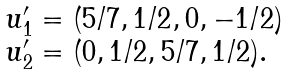<formula> <loc_0><loc_0><loc_500><loc_500>\begin{array} { l } { u } _ { 1 } ^ { \prime } = ( 5 / 7 , 1 / 2 , 0 , - 1 / 2 ) \\ { u } _ { 2 } ^ { \prime } = ( 0 , 1 / 2 , 5 / 7 , 1 / 2 ) . \end{array}</formula> 